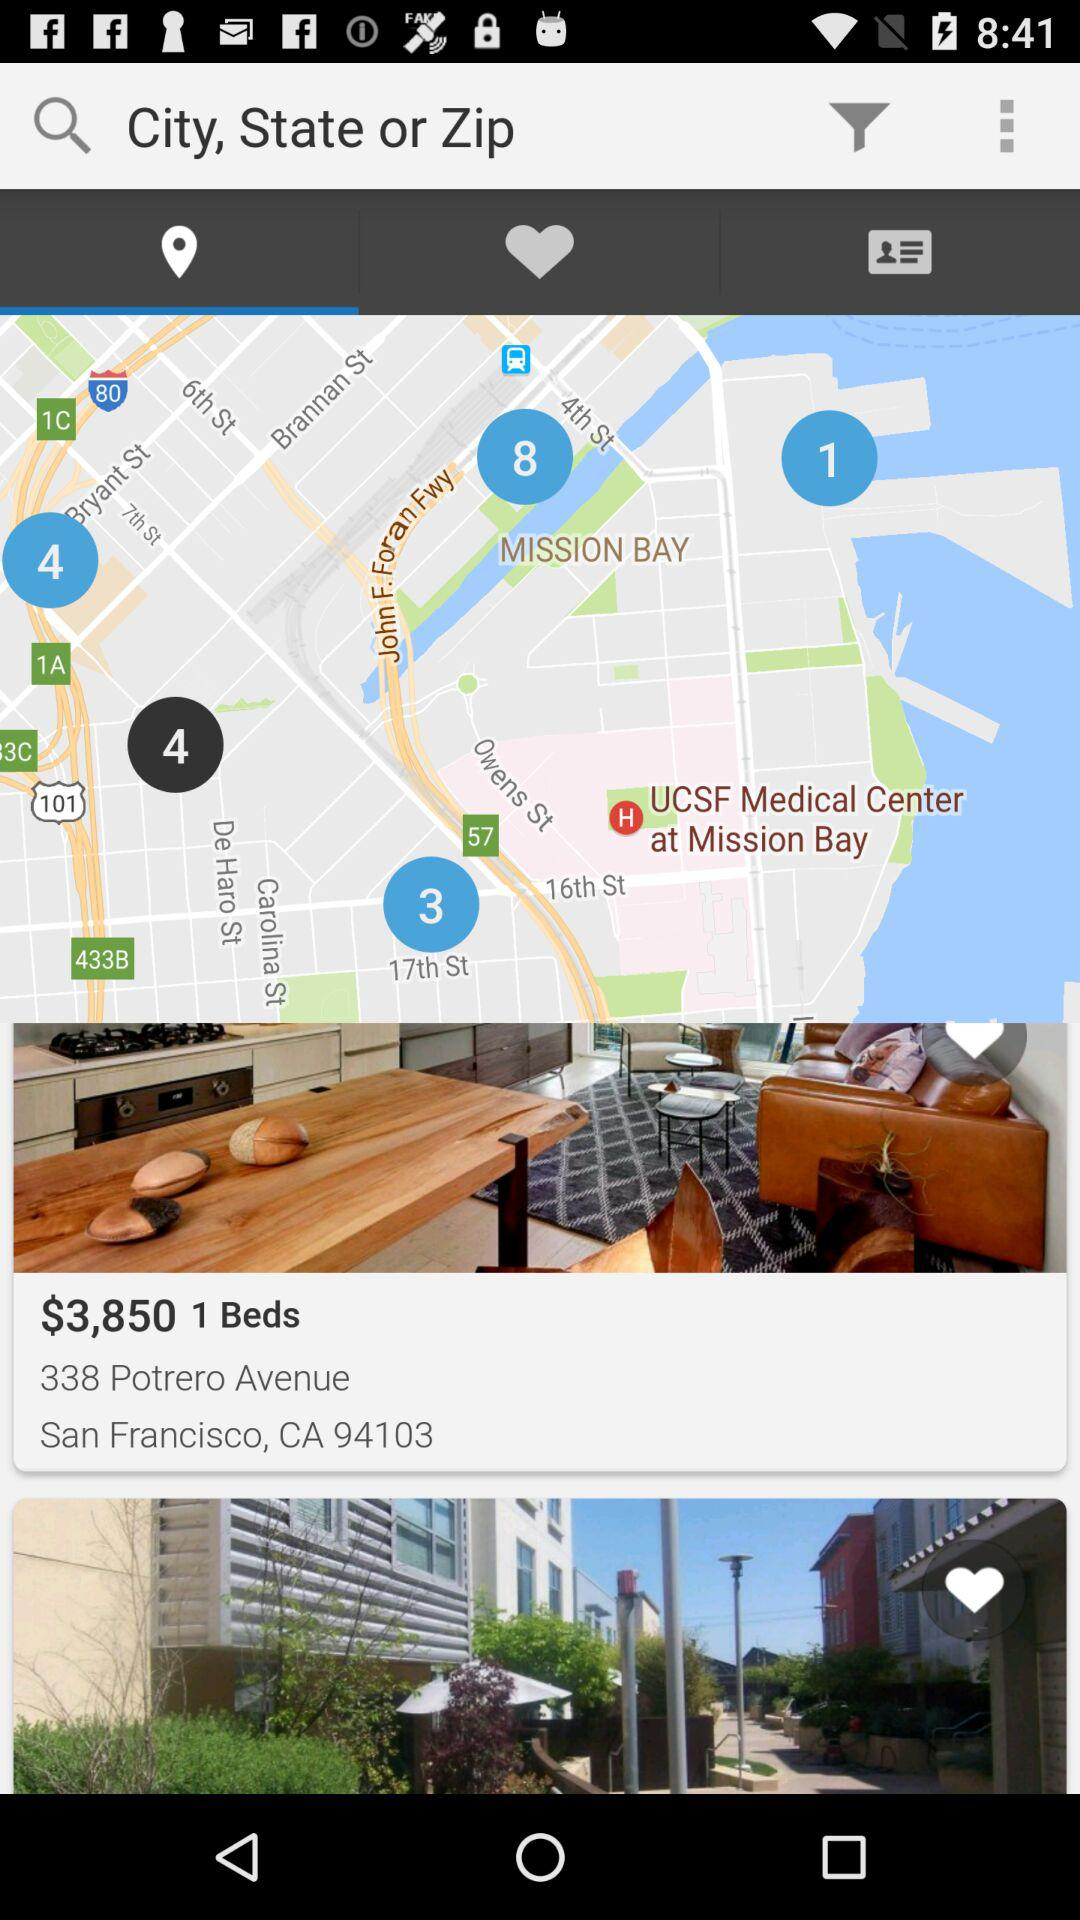What is the price of the room with 1 bed at 338 Potrero Avenue? The price of the room is $3,850. 